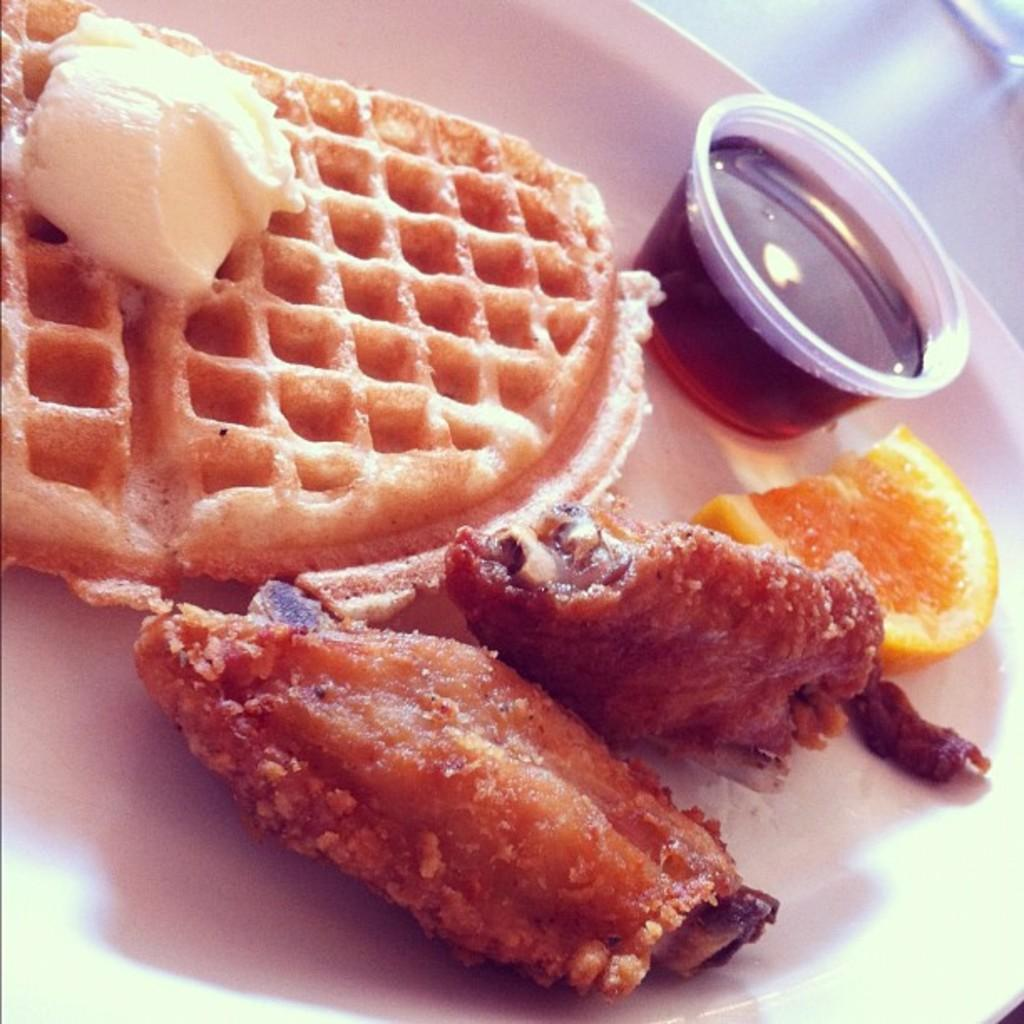What is on the plate in the image? There are food items on a white color plate in the image. What else can be seen in the image besides the plate? There is a bowl in the image. What colors are visible in the food items? The food has white, brown, and orange colors. What type of business is being conducted in the image? There is no indication of any business being conducted in the image; it primarily features food items on a plate and a bowl. 